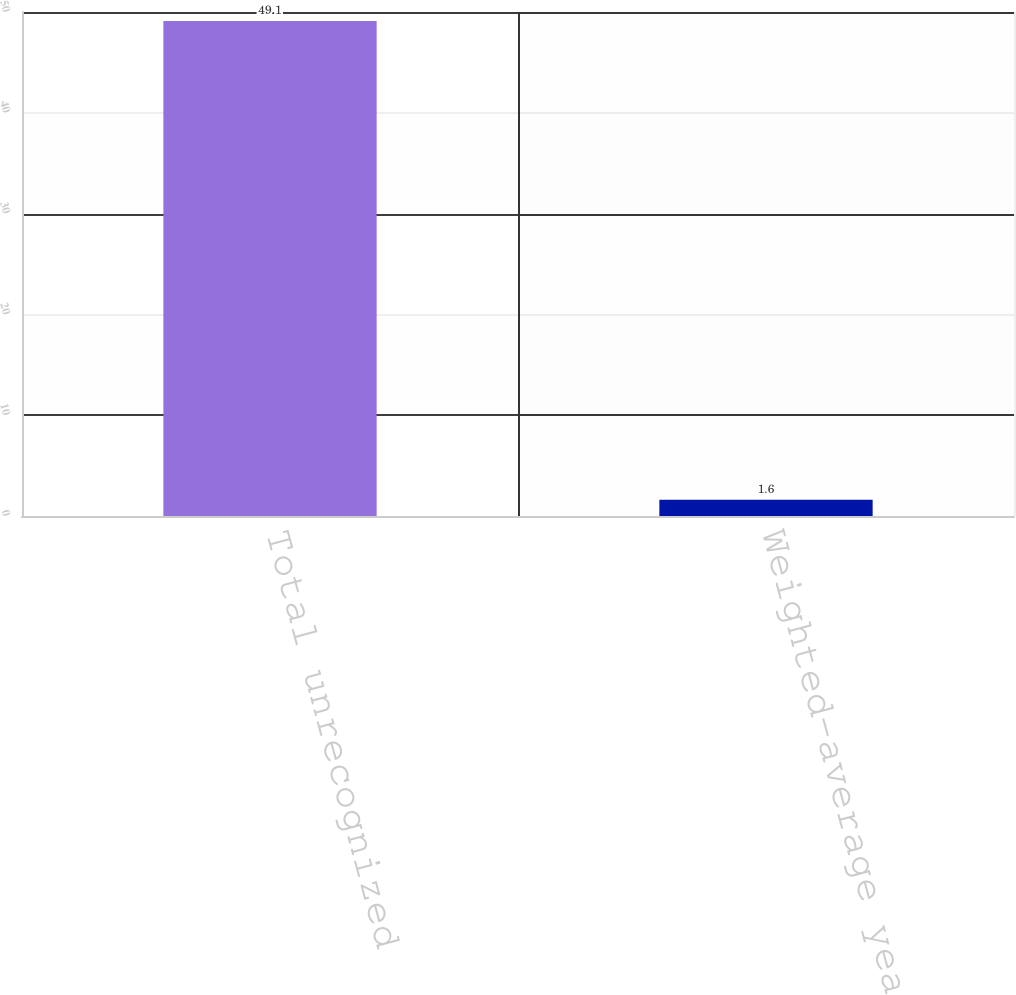Convert chart. <chart><loc_0><loc_0><loc_500><loc_500><bar_chart><fcel>Total unrecognized<fcel>Weighted-average years<nl><fcel>49.1<fcel>1.6<nl></chart> 